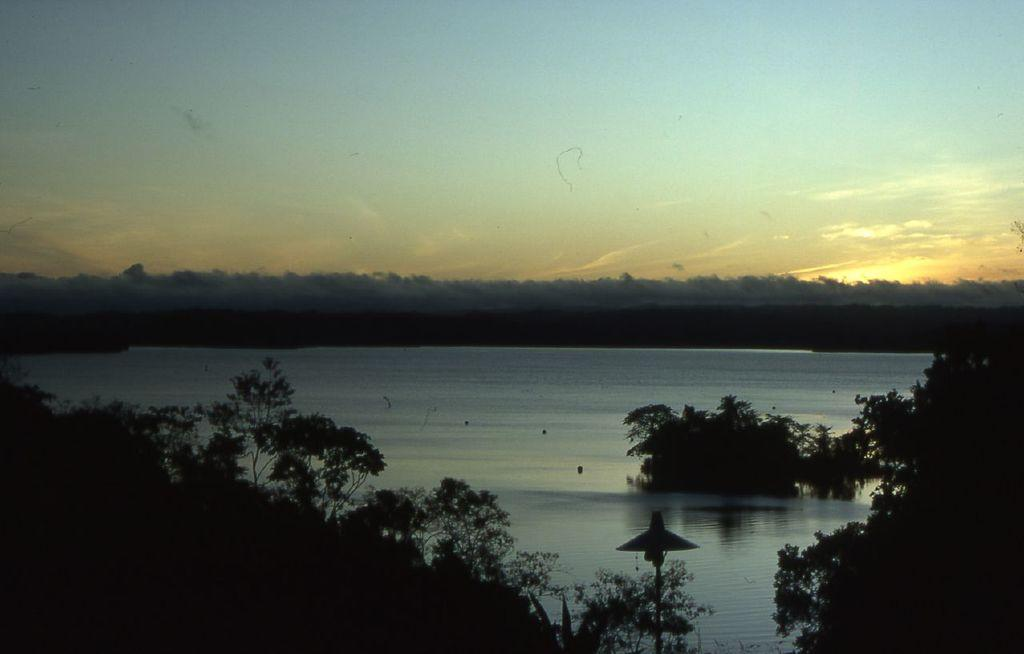What is present in the image that is not solid? There is water in the image. What type of vegetation can be seen in the image? There are trees in the image. What is the object in the image? The object in the image is not specified, but it is mentioned as being present. What can be seen in the distance in the image? The sky is visible in the background of the image. How many teeth can be seen in the image? There are no teeth present in the image. What type of jar is floating on the water in the image? There is no jar present in the image. 